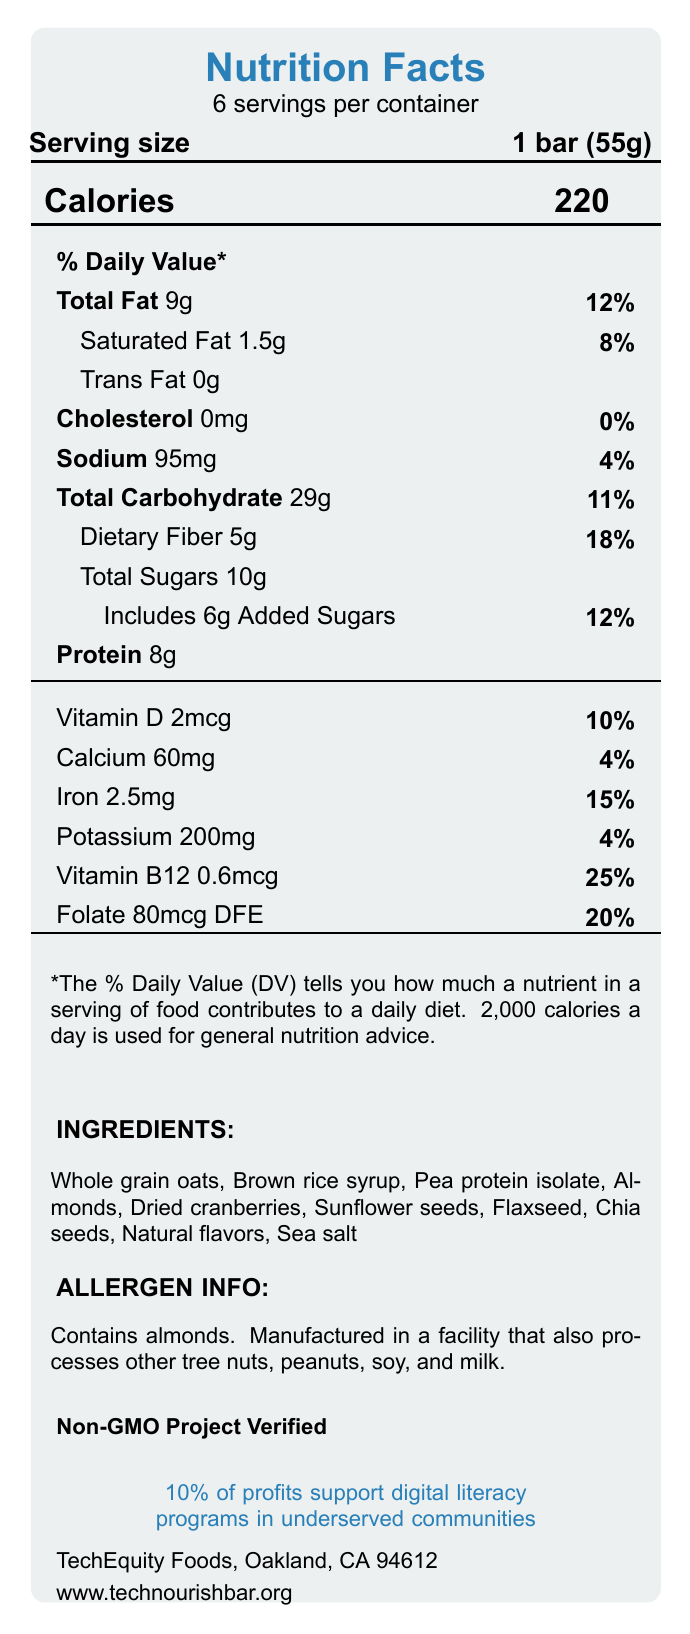what is the serving size of the TechNourish Bar? The serving size is explicitly stated as "1 bar (55g)" on the document.
Answer: 1 bar (55g) how many servings are in one container of TechNourish Bars? The document mentions there are 6 servings per container.
Answer: 6 how many calories are in a single serving of TechNourish Bar? The Calories section shows that each serving contains 220 calories.
Answer: 220 what is the amount of total fat in one serving? The Total Fat amount per serving is listed as "9g" on the document.
Answer: 9g how much dietary fiber does one bar contain? The Dietary Fiber content per serving is listed as "5g" on the document.
Answer: 5g what are the main ingredients in the TechNourish Bar? These ingredients are listed in the Ingredients section of the document.
Answer: Whole grain oats, Brown rice syrup, Pea protein isolate, Almonds, Dried cranberries, Sunflower seeds, Flaxseed, Chia seeds, Natural flavors, Sea salt is the TechNourish Bar certified non-GMO? The document states that the TechNourish Bar is Non-GMO Project Verified.
Answer: Yes how much sugar is there per bar? The Total Sugars content per serving is listed as "10g".
Answer: 10g how many grams of protein does the TechNourish Bar provide per serving? The Protein content per serving is listed as "8g".
Answer: 8g how much of the TechNourish Bar’s profits are directed towards digital literacy programs? The document mentions that 10% of profits support digital literacy programs in underserved communities.
Answer: 10% what is the daily value percentage of iron per serving? The Iron content’s daily value percentage is listed as "15%" on the document.
Answer: 15% which of the following is NOT an ingredient in the TechNourish Bar? A. Whole grain oats B. Brown rice syrup C. Apple pieces D. Chia seeds The ingredients listed do not include apple pieces.
Answer: C. Apple pieces what is the main purpose of the TechNourish Bar’s social impact initiative? A. Recycling B. Non-GMO certification C. Supporting digital literacy programs D. Food safety The document states that 10% of the profits support digital literacy programs in underserved communities.
Answer: C. Supporting digital literacy programs how long can the TechNourish Bar be stored before it expires? The shelf life of the product, when stored in a cool, dry place, is listed as "12 months".
Answer: 12 months what is the address of the manufacturer? The manufacturer listed is "TechEquity Foods, Oakland, CA 94612".
Answer: Oakland, CA 94612 can you identify any major allergens in the TechNourish Bar? The allergen information section states that it contains almonds and is manufactured in a facility that processes tree nuts, peanuts, soy, and milk.
Answer: Almonds do TechNourish Bars contain any trans fat? The document lists the Trans Fat content as "0g".
Answer: No summarize the main content of the document. The document comprehensively details everything about the TechNourish Bar, including nutritional content, ingredients, and its commitment to social impact.
Answer: The document presents the Nutrition Facts for the TechNourish Bar, a nutrient-dense snack designed to support digital literacy initiatives. It includes details on serving size, calories, nutrient content, ingredients, allergen information, certification, social impact, packaging, and shelf life. The bar contains 220 calories per serving, with substantial amounts of fiber, protein, and several vitamins and minerals. what are the exact natural flavors used in the TechNourish Bar? The document only mentions "Natural flavors" without specifying what they are exactly.
Answer: Not enough information 